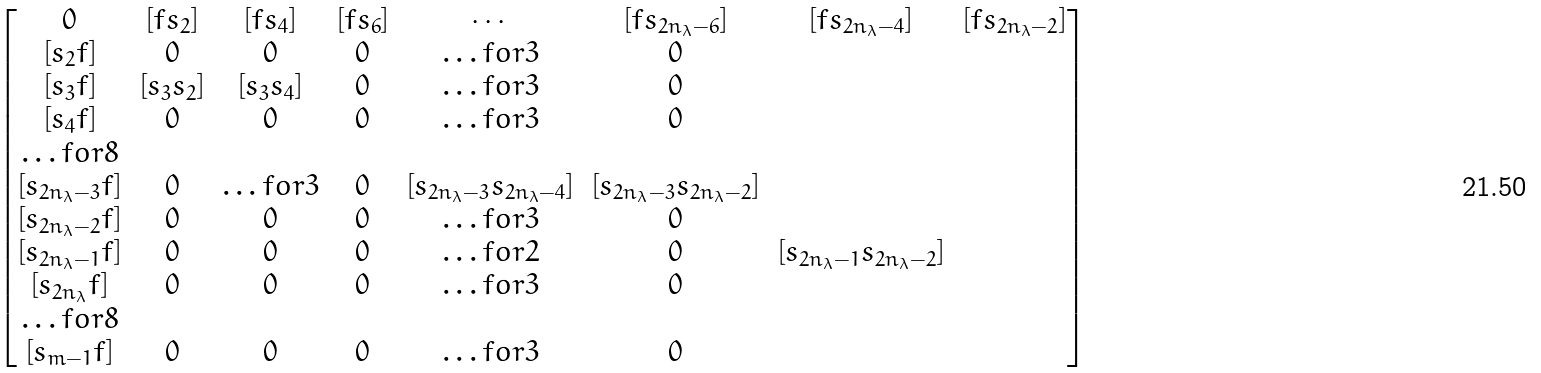<formula> <loc_0><loc_0><loc_500><loc_500>\begin{bmatrix} 0 & [ f s _ { 2 } ] & [ f s _ { 4 } ] & [ f s _ { 6 } ] & \cdots & [ f s _ { 2 n _ { \lambda } - 6 } ] & [ f s _ { 2 n _ { \lambda } - 4 } ] & [ f s _ { 2 n _ { \lambda } - 2 } ] \\ [ s _ { 2 } f ] & 0 & 0 & 0 & \hdots f o r { 3 } & 0 \\ [ s _ { 3 } f ] & [ s _ { 3 } s _ { 2 } ] & [ s _ { 3 } s _ { 4 } ] & 0 & \hdots f o r { 3 } & 0 \\ [ s _ { 4 } f ] & 0 & 0 & 0 & \hdots f o r { 3 } & 0 \\ \hdots f o r { 8 } \\ [ s _ { 2 n _ { \lambda } - 3 } f ] & 0 & \hdots f o r { 3 } & 0 & [ s _ { 2 n _ { \lambda } - 3 } s _ { 2 n _ { \lambda } - 4 } ] & [ s _ { 2 n _ { \lambda } - 3 } s _ { 2 n _ { \lambda } - 2 } ] \\ [ s _ { 2 n _ { \lambda } - 2 } f ] & 0 & 0 & 0 & \hdots f o r { 3 } & 0 \\ [ s _ { 2 n _ { \lambda } - 1 } f ] & 0 & 0 & 0 & \hdots f o r { 2 } & 0 & [ s _ { 2 n _ { \lambda } - 1 } s _ { 2 n _ { \lambda } - 2 } ] \\ [ s _ { 2 n _ { \lambda } } f ] & 0 & 0 & 0 & \hdots f o r { 3 } & 0 \\ \hdots f o r { 8 } \\ [ s _ { m - 1 } f ] & 0 & 0 & 0 & \hdots f o r { 3 } & 0 \end{bmatrix}</formula> 